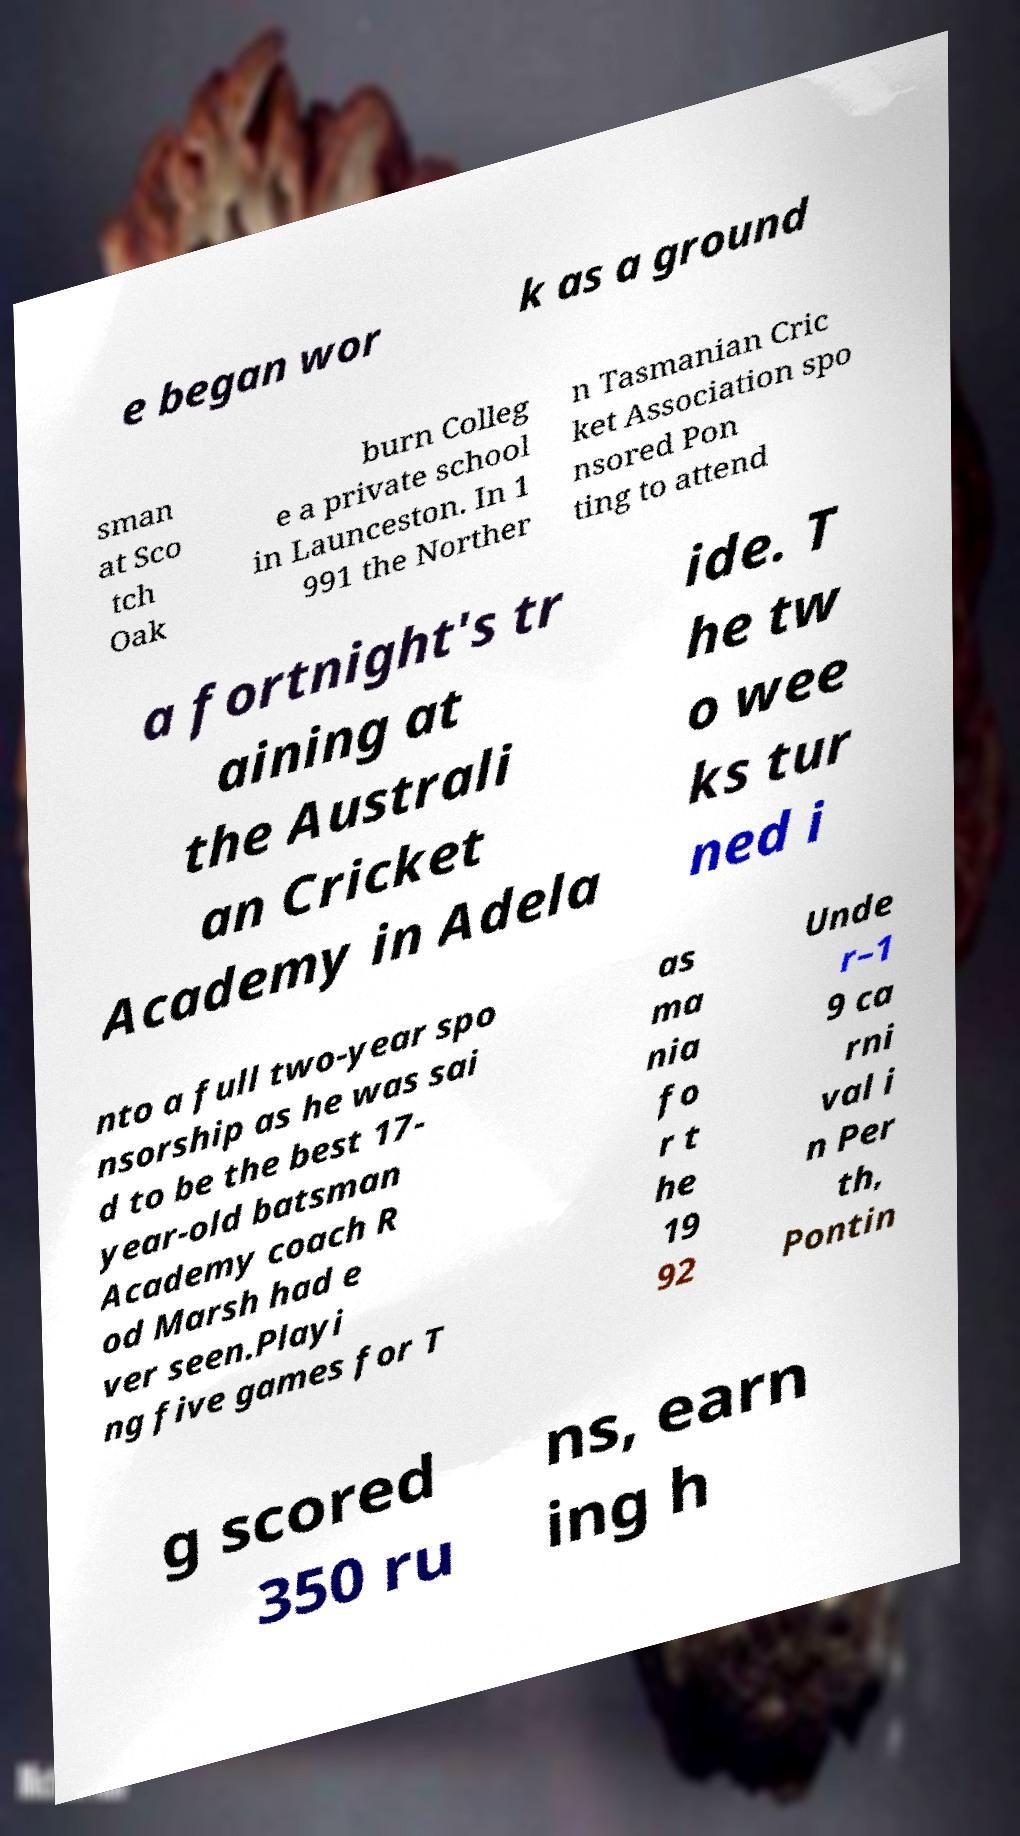For documentation purposes, I need the text within this image transcribed. Could you provide that? e began wor k as a ground sman at Sco tch Oak burn Colleg e a private school in Launceston. In 1 991 the Norther n Tasmanian Cric ket Association spo nsored Pon ting to attend a fortnight's tr aining at the Australi an Cricket Academy in Adela ide. T he tw o wee ks tur ned i nto a full two-year spo nsorship as he was sai d to be the best 17- year-old batsman Academy coach R od Marsh had e ver seen.Playi ng five games for T as ma nia fo r t he 19 92 Unde r–1 9 ca rni val i n Per th, Pontin g scored 350 ru ns, earn ing h 